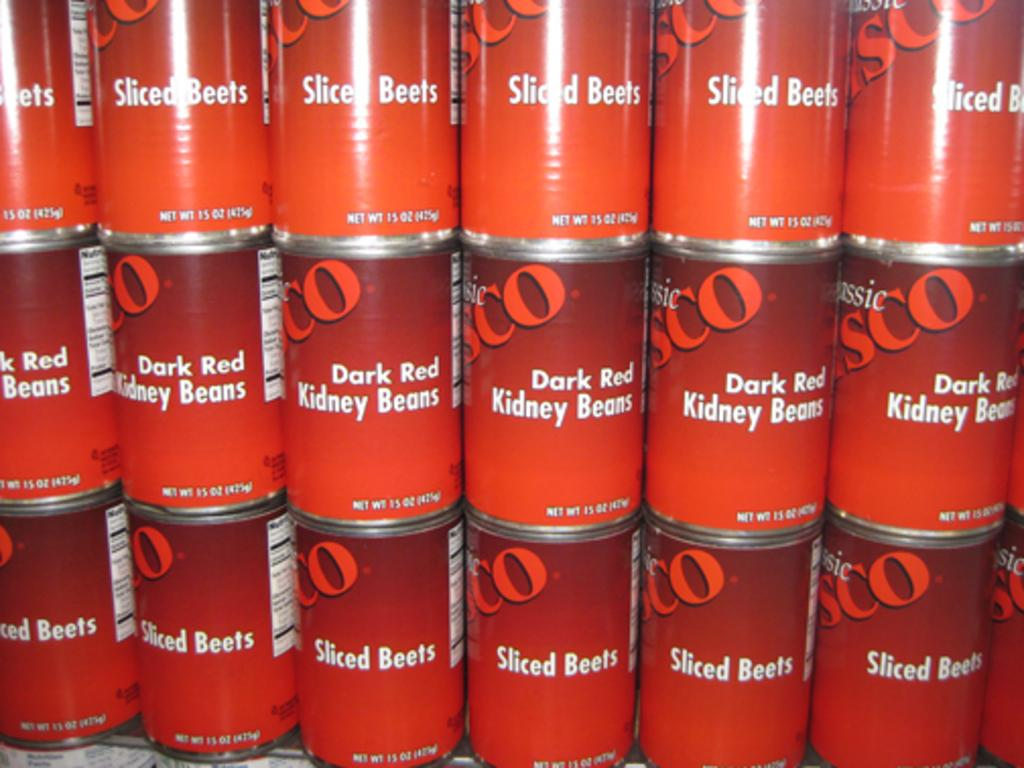<image>
Describe the image concisely. Stacks of canned vegetables in red labels including Sliced Beets and Dark Red Kidney Beans 